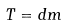<formula> <loc_0><loc_0><loc_500><loc_500>T = d m</formula> 